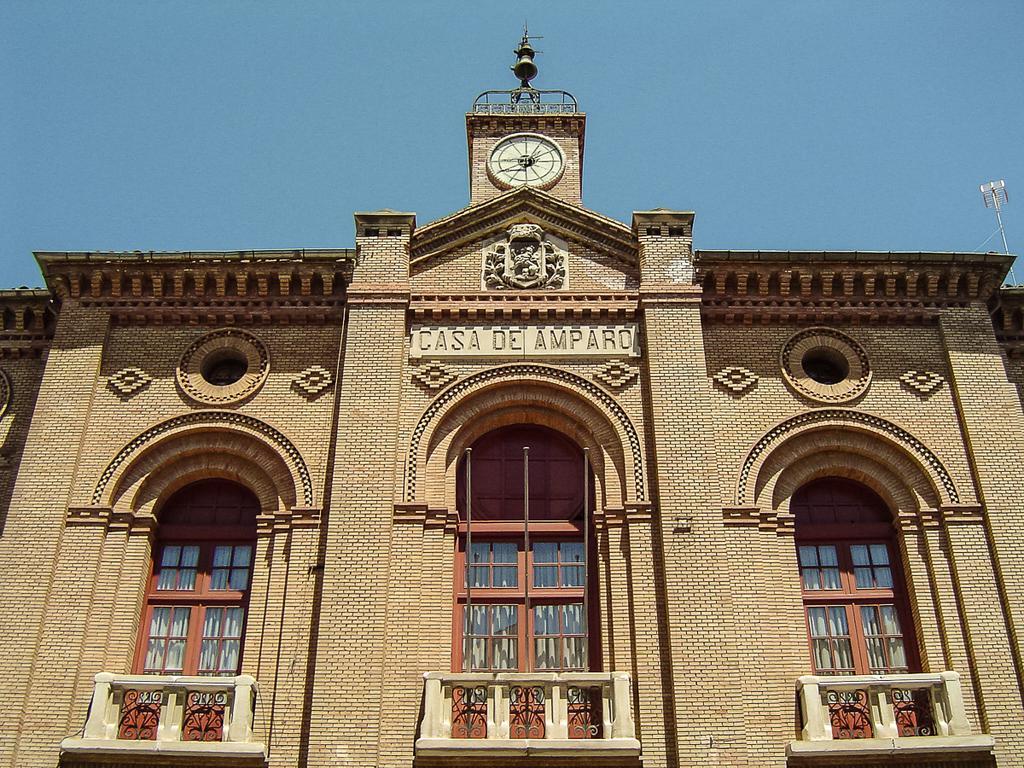Can you describe this image briefly? In this image there is a building with the glass windows. At the top there is a clock attached to the wall. At the top there is the sky. On the right side top there is a metal pole. 